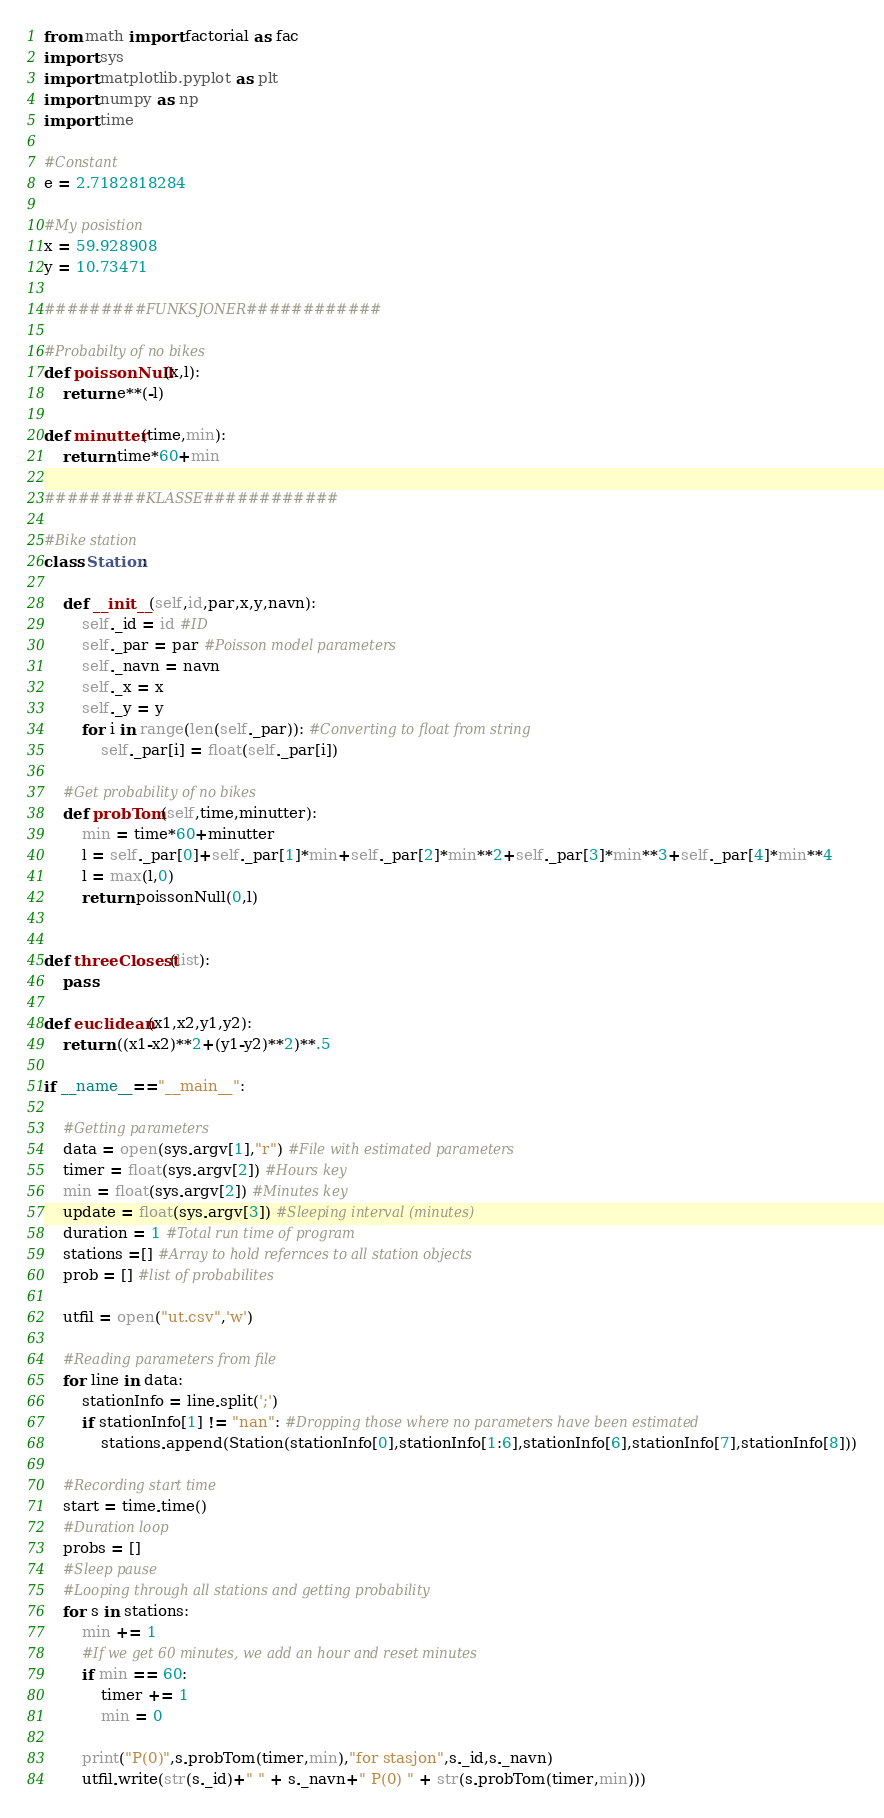Convert code to text. <code><loc_0><loc_0><loc_500><loc_500><_Python_>

from math import factorial as fac
import sys
import matplotlib.pyplot as plt
import numpy as np
import time

#Constant
e = 2.7182818284

#My posistion
x = 59.928908
y = 10.73471

#########FUNKSJONER############

#Probabilty of no bikes
def poissonNull(x,l):
    return e**(-l)

def minutter(time,min):
    return time*60+min

#########KLASSE############

#Bike station
class Station:

    def __init__(self,id,par,x,y,navn):
        self._id = id #ID
        self._par = par #Poisson model parameters
        self._navn = navn
        self._x = x
        self._y = y
        for i in range(len(self._par)): #Converting to float from string
            self._par[i] = float(self._par[i])

    #Get probability of no bikes
    def probTom(self,time,minutter):
        min = time*60+minutter
        l = self._par[0]+self._par[1]*min+self._par[2]*min**2+self._par[3]*min**3+self._par[4]*min**4
        l = max(l,0)
        return poissonNull(0,l)


def threeClosest(list):
    pass

def euclidean(x1,x2,y1,y2):
    return ((x1-x2)**2+(y1-y2)**2)**.5

if __name__=="__main__":

    #Getting parameters
    data = open(sys.argv[1],"r") #File with estimated parameters
    timer = float(sys.argv[2]) #Hours key
    min = float(sys.argv[2]) #Minutes key
    update = float(sys.argv[3]) #Sleeping interval (minutes)
    duration = 1 #Total run time of program
    stations =[] #Array to hold refernces to all station objects
    prob = [] #list of probabilites

    utfil = open("ut.csv",'w')

    #Reading parameters from file
    for line in data:
        stationInfo = line.split(';')
        if stationInfo[1] != "nan": #Dropping those where no parameters have been estimated
            stations.append(Station(stationInfo[0],stationInfo[1:6],stationInfo[6],stationInfo[7],stationInfo[8]))

    #Recording start time
    start = time.time()
    #Duration loop
    probs = []
    #Sleep pause
    #Looping through all stations and getting probability
    for s in stations:
        min += 1
        #If we get 60 minutes, we add an hour and reset minutes
        if min == 60:
            timer += 1
            min = 0

        print("P(0)",s.probTom(timer,min),"for stasjon",s._id,s._navn)
        utfil.write(str(s._id)+" " + s._navn+" P(0) " + str(s.probTom(timer,min)))
</code> 